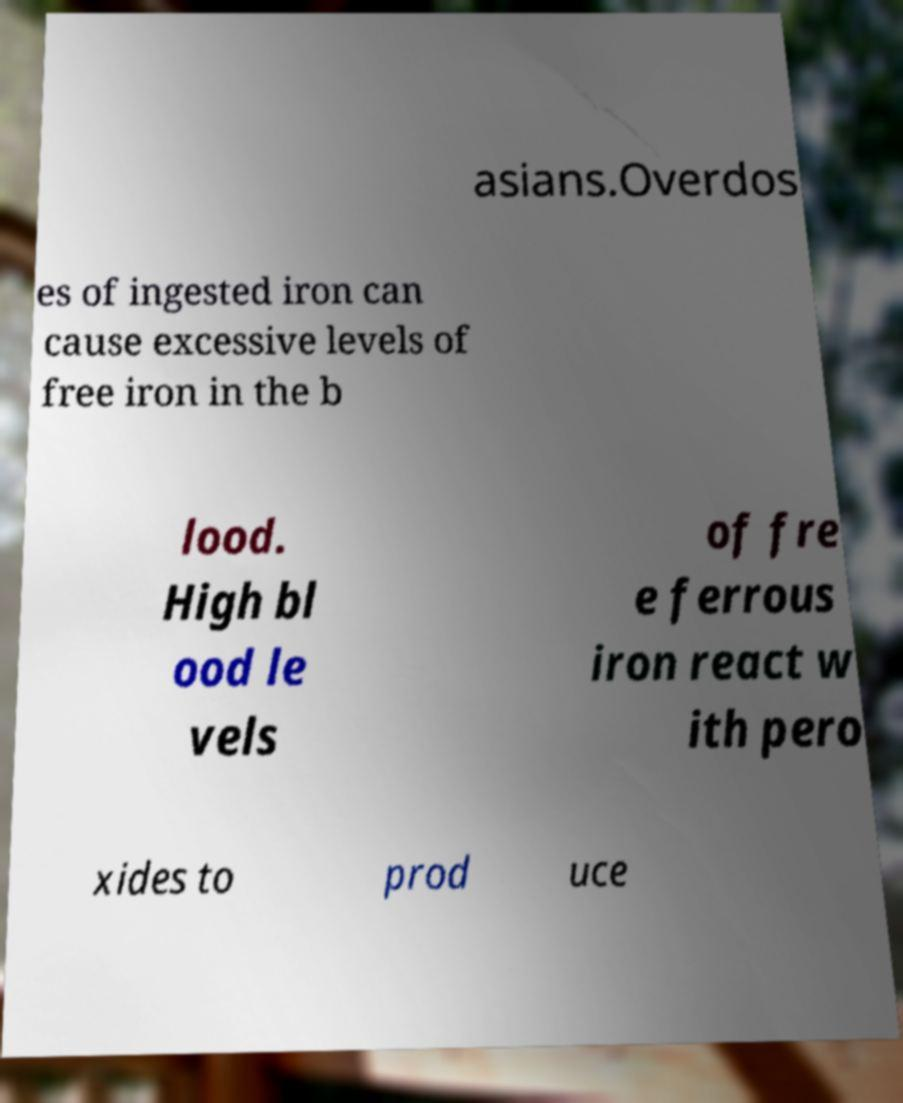What messages or text are displayed in this image? I need them in a readable, typed format. asians.Overdos es of ingested iron can cause excessive levels of free iron in the b lood. High bl ood le vels of fre e ferrous iron react w ith pero xides to prod uce 